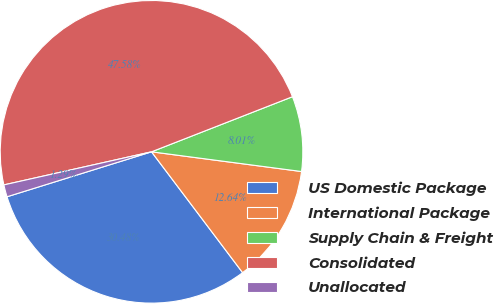Convert chart. <chart><loc_0><loc_0><loc_500><loc_500><pie_chart><fcel>US Domestic Package<fcel>International Package<fcel>Supply Chain & Freight<fcel>Consolidated<fcel>Unallocated<nl><fcel>30.48%<fcel>12.64%<fcel>8.01%<fcel>47.58%<fcel>1.29%<nl></chart> 